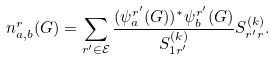<formula> <loc_0><loc_0><loc_500><loc_500>n ^ { r } _ { a , b } ( G ) = \sum _ { r ^ { \prime } \in \mathcal { E } } \frac { ( \psi _ { a } ^ { r ^ { \prime } } ( G ) ) ^ { * } \psi _ { b } ^ { r ^ { \prime } } ( G ) } { S ^ { ( k ) } _ { 1 r ^ { \prime } } } S ^ { ( k ) } _ { r ^ { \prime } r } .</formula> 